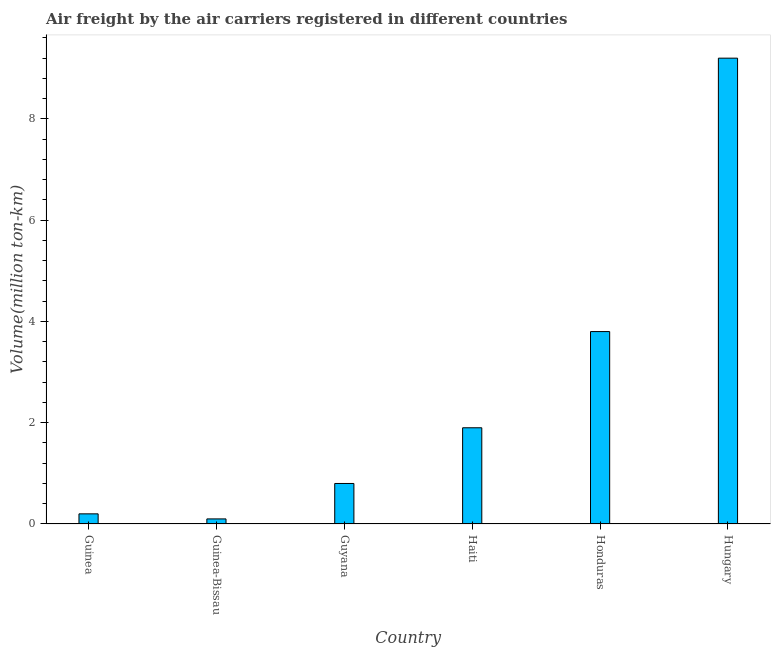What is the title of the graph?
Ensure brevity in your answer.  Air freight by the air carriers registered in different countries. What is the label or title of the X-axis?
Offer a terse response. Country. What is the label or title of the Y-axis?
Your response must be concise. Volume(million ton-km). What is the air freight in Guinea-Bissau?
Your response must be concise. 0.1. Across all countries, what is the maximum air freight?
Provide a succinct answer. 9.2. Across all countries, what is the minimum air freight?
Your answer should be very brief. 0.1. In which country was the air freight maximum?
Your answer should be very brief. Hungary. In which country was the air freight minimum?
Offer a very short reply. Guinea-Bissau. What is the sum of the air freight?
Your answer should be very brief. 16. What is the average air freight per country?
Provide a short and direct response. 2.67. What is the median air freight?
Provide a short and direct response. 1.35. What is the ratio of the air freight in Guinea to that in Hungary?
Offer a terse response. 0.02. What is the difference between the highest and the second highest air freight?
Give a very brief answer. 5.4. Is the sum of the air freight in Haiti and Hungary greater than the maximum air freight across all countries?
Your answer should be compact. Yes. In how many countries, is the air freight greater than the average air freight taken over all countries?
Provide a succinct answer. 2. How many bars are there?
Offer a very short reply. 6. Are all the bars in the graph horizontal?
Your answer should be very brief. No. Are the values on the major ticks of Y-axis written in scientific E-notation?
Provide a short and direct response. No. What is the Volume(million ton-km) in Guinea?
Keep it short and to the point. 0.2. What is the Volume(million ton-km) in Guinea-Bissau?
Your answer should be compact. 0.1. What is the Volume(million ton-km) of Guyana?
Your answer should be very brief. 0.8. What is the Volume(million ton-km) in Haiti?
Give a very brief answer. 1.9. What is the Volume(million ton-km) of Honduras?
Ensure brevity in your answer.  3.8. What is the Volume(million ton-km) in Hungary?
Offer a very short reply. 9.2. What is the difference between the Volume(million ton-km) in Guinea and Haiti?
Offer a very short reply. -1.7. What is the difference between the Volume(million ton-km) in Guinea-Bissau and Guyana?
Provide a short and direct response. -0.7. What is the difference between the Volume(million ton-km) in Guinea-Bissau and Honduras?
Provide a short and direct response. -3.7. What is the difference between the Volume(million ton-km) in Guyana and Haiti?
Offer a very short reply. -1.1. What is the difference between the Volume(million ton-km) in Guyana and Honduras?
Your response must be concise. -3. What is the difference between the Volume(million ton-km) in Guyana and Hungary?
Give a very brief answer. -8.4. What is the difference between the Volume(million ton-km) in Haiti and Honduras?
Offer a terse response. -1.9. What is the difference between the Volume(million ton-km) in Haiti and Hungary?
Make the answer very short. -7.3. What is the ratio of the Volume(million ton-km) in Guinea to that in Guinea-Bissau?
Give a very brief answer. 2. What is the ratio of the Volume(million ton-km) in Guinea to that in Guyana?
Provide a short and direct response. 0.25. What is the ratio of the Volume(million ton-km) in Guinea to that in Haiti?
Offer a terse response. 0.1. What is the ratio of the Volume(million ton-km) in Guinea to that in Honduras?
Provide a short and direct response. 0.05. What is the ratio of the Volume(million ton-km) in Guinea to that in Hungary?
Your answer should be compact. 0.02. What is the ratio of the Volume(million ton-km) in Guinea-Bissau to that in Guyana?
Provide a succinct answer. 0.12. What is the ratio of the Volume(million ton-km) in Guinea-Bissau to that in Haiti?
Make the answer very short. 0.05. What is the ratio of the Volume(million ton-km) in Guinea-Bissau to that in Honduras?
Provide a short and direct response. 0.03. What is the ratio of the Volume(million ton-km) in Guinea-Bissau to that in Hungary?
Keep it short and to the point. 0.01. What is the ratio of the Volume(million ton-km) in Guyana to that in Haiti?
Provide a succinct answer. 0.42. What is the ratio of the Volume(million ton-km) in Guyana to that in Honduras?
Make the answer very short. 0.21. What is the ratio of the Volume(million ton-km) in Guyana to that in Hungary?
Ensure brevity in your answer.  0.09. What is the ratio of the Volume(million ton-km) in Haiti to that in Hungary?
Provide a succinct answer. 0.21. What is the ratio of the Volume(million ton-km) in Honduras to that in Hungary?
Provide a short and direct response. 0.41. 